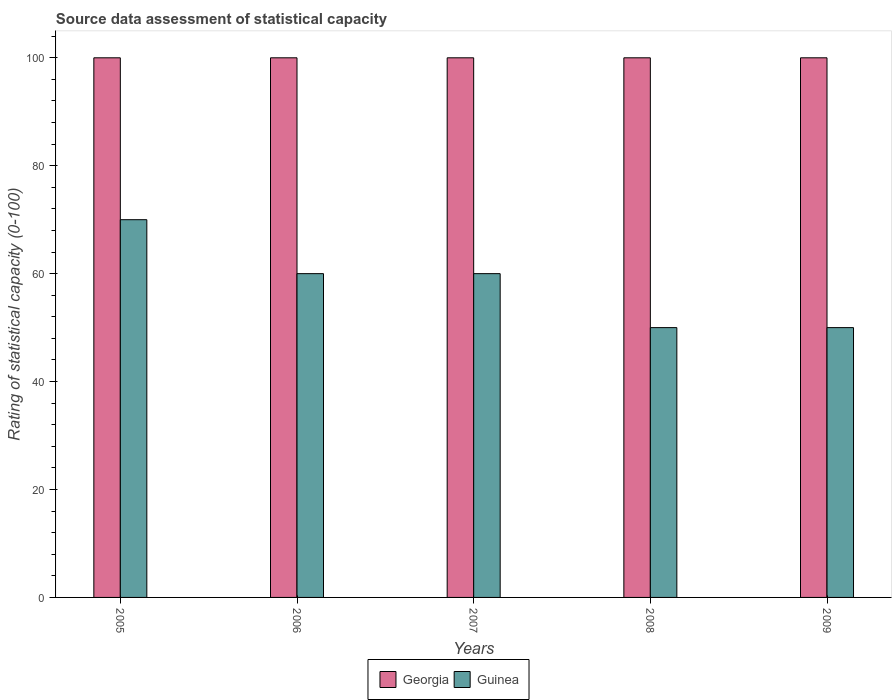How many different coloured bars are there?
Provide a short and direct response. 2. How many groups of bars are there?
Give a very brief answer. 5. Are the number of bars per tick equal to the number of legend labels?
Your answer should be compact. Yes. Are the number of bars on each tick of the X-axis equal?
Ensure brevity in your answer.  Yes. How many bars are there on the 1st tick from the right?
Make the answer very short. 2. What is the rating of statistical capacity in Georgia in 2006?
Provide a short and direct response. 100. Across all years, what is the maximum rating of statistical capacity in Guinea?
Your response must be concise. 70. Across all years, what is the minimum rating of statistical capacity in Guinea?
Keep it short and to the point. 50. In which year was the rating of statistical capacity in Georgia maximum?
Offer a very short reply. 2005. In which year was the rating of statistical capacity in Guinea minimum?
Offer a very short reply. 2008. What is the total rating of statistical capacity in Georgia in the graph?
Give a very brief answer. 500. What is the difference between the rating of statistical capacity in Georgia in 2005 and that in 2006?
Provide a short and direct response. 0. What is the difference between the rating of statistical capacity in Georgia in 2005 and the rating of statistical capacity in Guinea in 2009?
Keep it short and to the point. 50. In the year 2008, what is the difference between the rating of statistical capacity in Georgia and rating of statistical capacity in Guinea?
Keep it short and to the point. 50. In how many years, is the rating of statistical capacity in Guinea greater than 56?
Make the answer very short. 3. What is the ratio of the rating of statistical capacity in Guinea in 2005 to that in 2006?
Keep it short and to the point. 1.17. What is the difference between the highest and the second highest rating of statistical capacity in Guinea?
Offer a very short reply. 10. What is the difference between the highest and the lowest rating of statistical capacity in Georgia?
Your answer should be compact. 0. In how many years, is the rating of statistical capacity in Guinea greater than the average rating of statistical capacity in Guinea taken over all years?
Your answer should be compact. 3. What does the 1st bar from the left in 2008 represents?
Keep it short and to the point. Georgia. What does the 1st bar from the right in 2009 represents?
Ensure brevity in your answer.  Guinea. Are all the bars in the graph horizontal?
Your answer should be compact. No. What is the difference between two consecutive major ticks on the Y-axis?
Provide a succinct answer. 20. Does the graph contain grids?
Give a very brief answer. No. How many legend labels are there?
Keep it short and to the point. 2. What is the title of the graph?
Provide a short and direct response. Source data assessment of statistical capacity. What is the label or title of the X-axis?
Offer a very short reply. Years. What is the label or title of the Y-axis?
Your answer should be very brief. Rating of statistical capacity (0-100). What is the Rating of statistical capacity (0-100) in Guinea in 2005?
Provide a succinct answer. 70. What is the Rating of statistical capacity (0-100) of Georgia in 2006?
Keep it short and to the point. 100. What is the Rating of statistical capacity (0-100) in Guinea in 2006?
Give a very brief answer. 60. What is the Rating of statistical capacity (0-100) in Georgia in 2007?
Offer a terse response. 100. What is the Rating of statistical capacity (0-100) in Guinea in 2007?
Give a very brief answer. 60. What is the Rating of statistical capacity (0-100) in Georgia in 2008?
Your response must be concise. 100. What is the Rating of statistical capacity (0-100) of Guinea in 2008?
Your answer should be very brief. 50. What is the Rating of statistical capacity (0-100) in Georgia in 2009?
Your answer should be very brief. 100. Across all years, what is the minimum Rating of statistical capacity (0-100) of Georgia?
Offer a terse response. 100. Across all years, what is the minimum Rating of statistical capacity (0-100) in Guinea?
Make the answer very short. 50. What is the total Rating of statistical capacity (0-100) in Georgia in the graph?
Provide a succinct answer. 500. What is the total Rating of statistical capacity (0-100) of Guinea in the graph?
Your answer should be compact. 290. What is the difference between the Rating of statistical capacity (0-100) of Georgia in 2005 and that in 2006?
Your answer should be very brief. 0. What is the difference between the Rating of statistical capacity (0-100) in Georgia in 2005 and that in 2007?
Offer a very short reply. 0. What is the difference between the Rating of statistical capacity (0-100) in Guinea in 2005 and that in 2007?
Your response must be concise. 10. What is the difference between the Rating of statistical capacity (0-100) in Guinea in 2005 and that in 2008?
Your answer should be very brief. 20. What is the difference between the Rating of statistical capacity (0-100) in Georgia in 2005 and that in 2009?
Give a very brief answer. 0. What is the difference between the Rating of statistical capacity (0-100) in Georgia in 2006 and that in 2007?
Provide a succinct answer. 0. What is the difference between the Rating of statistical capacity (0-100) in Guinea in 2006 and that in 2007?
Your answer should be compact. 0. What is the difference between the Rating of statistical capacity (0-100) in Georgia in 2006 and that in 2008?
Ensure brevity in your answer.  0. What is the difference between the Rating of statistical capacity (0-100) in Guinea in 2006 and that in 2009?
Provide a succinct answer. 10. What is the difference between the Rating of statistical capacity (0-100) of Guinea in 2007 and that in 2008?
Make the answer very short. 10. What is the difference between the Rating of statistical capacity (0-100) in Guinea in 2007 and that in 2009?
Make the answer very short. 10. What is the difference between the Rating of statistical capacity (0-100) of Guinea in 2008 and that in 2009?
Your answer should be very brief. 0. What is the difference between the Rating of statistical capacity (0-100) of Georgia in 2005 and the Rating of statistical capacity (0-100) of Guinea in 2006?
Give a very brief answer. 40. What is the difference between the Rating of statistical capacity (0-100) of Georgia in 2005 and the Rating of statistical capacity (0-100) of Guinea in 2007?
Give a very brief answer. 40. What is the difference between the Rating of statistical capacity (0-100) in Georgia in 2005 and the Rating of statistical capacity (0-100) in Guinea in 2008?
Provide a succinct answer. 50. What is the difference between the Rating of statistical capacity (0-100) of Georgia in 2005 and the Rating of statistical capacity (0-100) of Guinea in 2009?
Offer a terse response. 50. What is the difference between the Rating of statistical capacity (0-100) in Georgia in 2006 and the Rating of statistical capacity (0-100) in Guinea in 2007?
Make the answer very short. 40. What is the average Rating of statistical capacity (0-100) of Georgia per year?
Give a very brief answer. 100. In the year 2005, what is the difference between the Rating of statistical capacity (0-100) of Georgia and Rating of statistical capacity (0-100) of Guinea?
Make the answer very short. 30. What is the ratio of the Rating of statistical capacity (0-100) in Georgia in 2005 to that in 2006?
Provide a succinct answer. 1. What is the ratio of the Rating of statistical capacity (0-100) of Georgia in 2005 to that in 2007?
Offer a terse response. 1. What is the ratio of the Rating of statistical capacity (0-100) of Georgia in 2005 to that in 2008?
Ensure brevity in your answer.  1. What is the ratio of the Rating of statistical capacity (0-100) in Guinea in 2005 to that in 2008?
Keep it short and to the point. 1.4. What is the ratio of the Rating of statistical capacity (0-100) of Georgia in 2005 to that in 2009?
Your answer should be compact. 1. What is the ratio of the Rating of statistical capacity (0-100) of Georgia in 2006 to that in 2008?
Make the answer very short. 1. What is the ratio of the Rating of statistical capacity (0-100) in Guinea in 2007 to that in 2008?
Your answer should be very brief. 1.2. What is the ratio of the Rating of statistical capacity (0-100) in Georgia in 2008 to that in 2009?
Your answer should be compact. 1. What is the difference between the highest and the lowest Rating of statistical capacity (0-100) of Georgia?
Give a very brief answer. 0. What is the difference between the highest and the lowest Rating of statistical capacity (0-100) in Guinea?
Give a very brief answer. 20. 